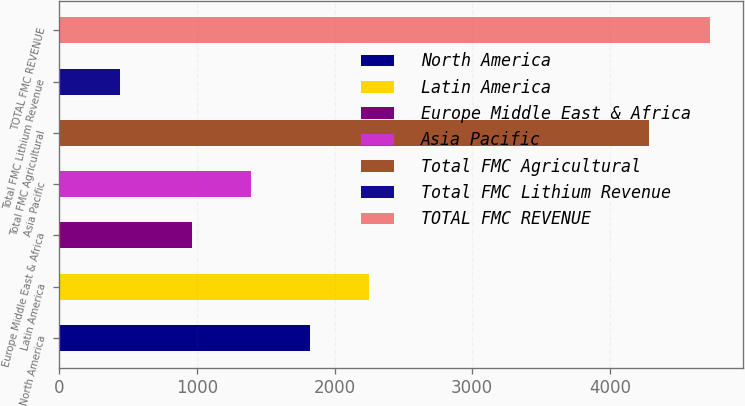Convert chart. <chart><loc_0><loc_0><loc_500><loc_500><bar_chart><fcel>North America<fcel>Latin America<fcel>Europe Middle East & Africa<fcel>Asia Pacific<fcel>Total FMC Agricultural<fcel>Total FMC Lithium Revenue<fcel>TOTAL FMC REVENUE<nl><fcel>1823.06<fcel>2251.59<fcel>966<fcel>1394.53<fcel>4285.3<fcel>442.5<fcel>4727.8<nl></chart> 